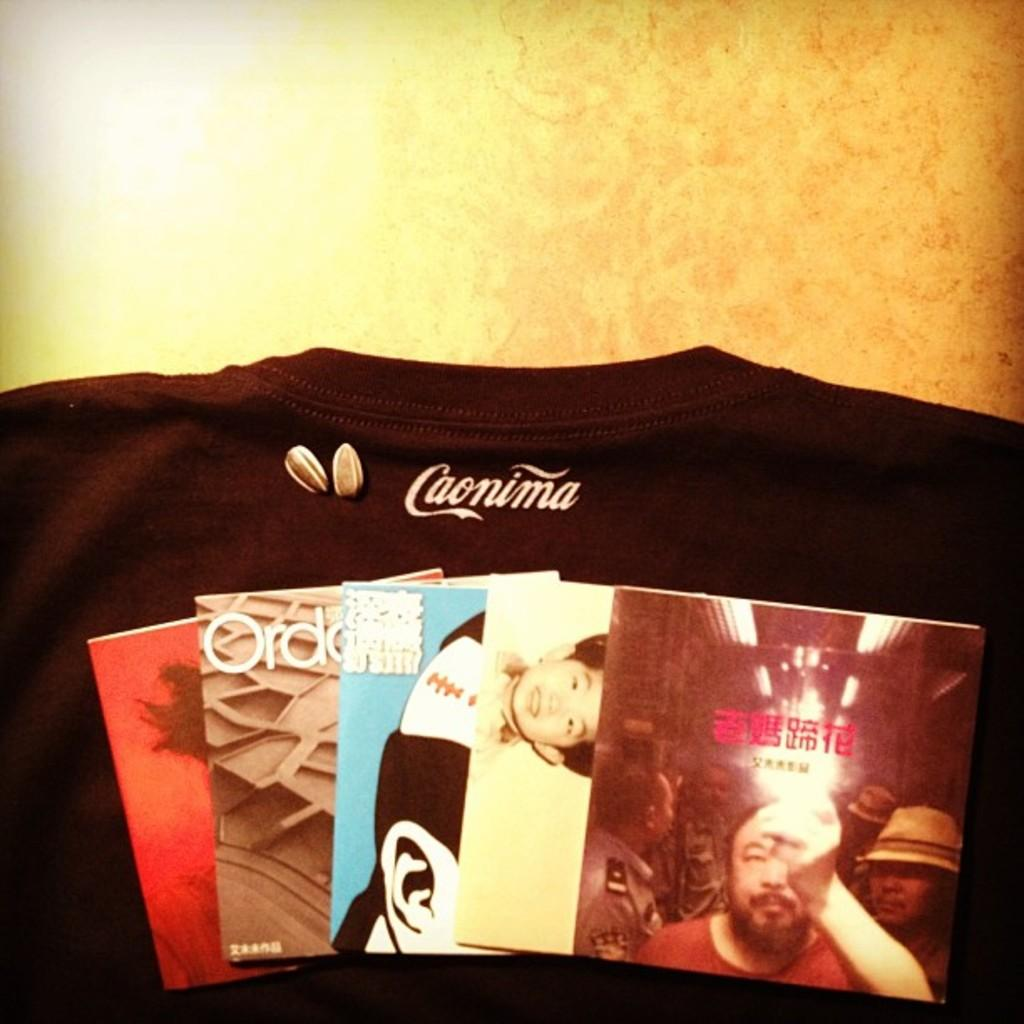What type of clothing item is visible in the image? There is a t-shirt in the image. What else can be seen in the image besides the t-shirt? There are cards with pictures in the image. Where are the cards placed in the image? The cards are placed on a surface. What type of gold ornament is hanging from the arch in the image? There is no gold ornament or arch present in the image. 